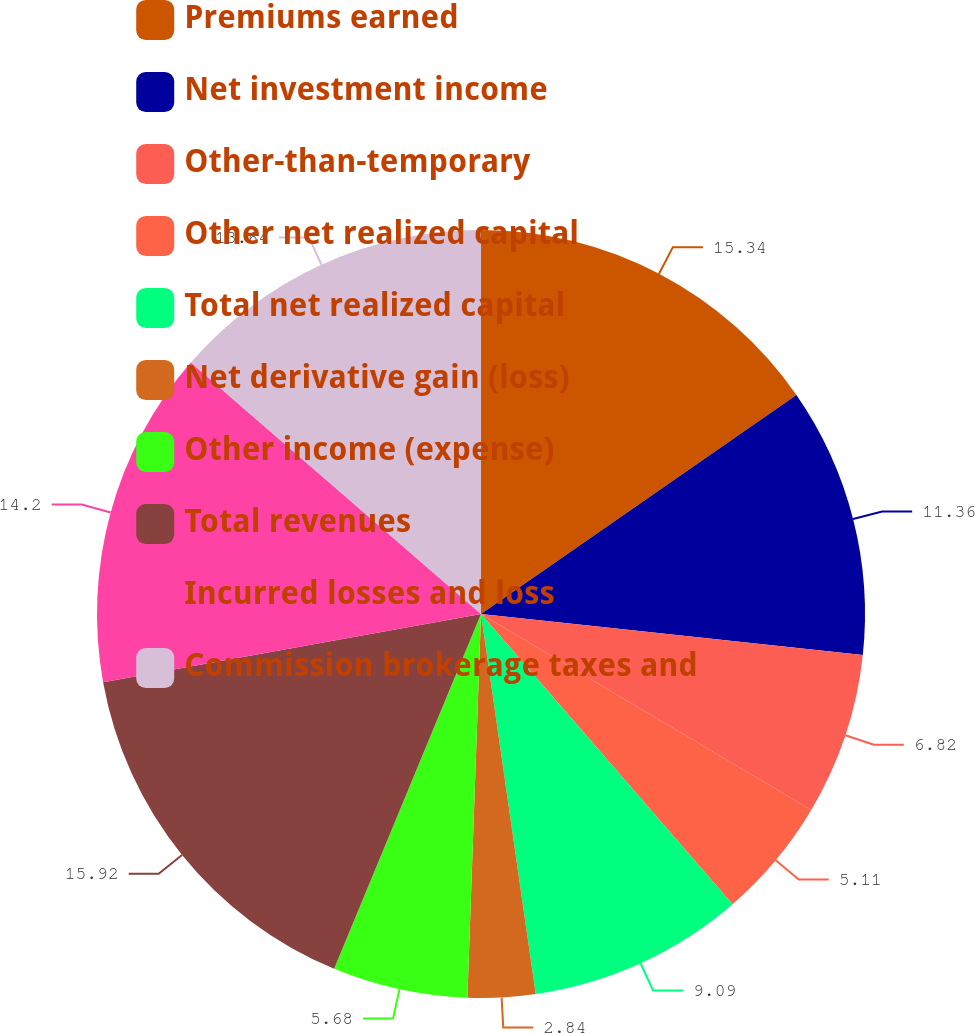Convert chart to OTSL. <chart><loc_0><loc_0><loc_500><loc_500><pie_chart><fcel>Premiums earned<fcel>Net investment income<fcel>Other-than-temporary<fcel>Other net realized capital<fcel>Total net realized capital<fcel>Net derivative gain (loss)<fcel>Other income (expense)<fcel>Total revenues<fcel>Incurred losses and loss<fcel>Commission brokerage taxes and<nl><fcel>15.34%<fcel>11.36%<fcel>6.82%<fcel>5.11%<fcel>9.09%<fcel>2.84%<fcel>5.68%<fcel>15.91%<fcel>14.2%<fcel>13.64%<nl></chart> 